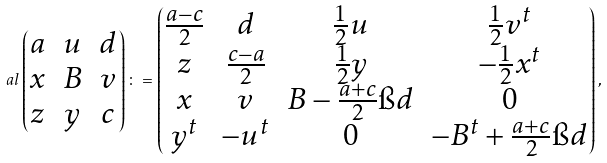<formula> <loc_0><loc_0><loc_500><loc_500>\ a l \begin{pmatrix} a & u & d \\ x & B & v \\ z & y & c \end{pmatrix} \colon = \begin{pmatrix} \frac { a - c } { 2 } & d & \frac { 1 } { 2 } u & \frac { 1 } { 2 } v ^ { t } \\ z & \frac { c - a } { 2 } & \frac { 1 } { 2 } y & - \frac { 1 } { 2 } x ^ { t } \\ x & v & B - \frac { a + c } { 2 } \i d & 0 \\ y ^ { t } & - u ^ { t } & 0 & - B ^ { t } + \frac { a + c } { 2 } \i d \end{pmatrix} ,</formula> 